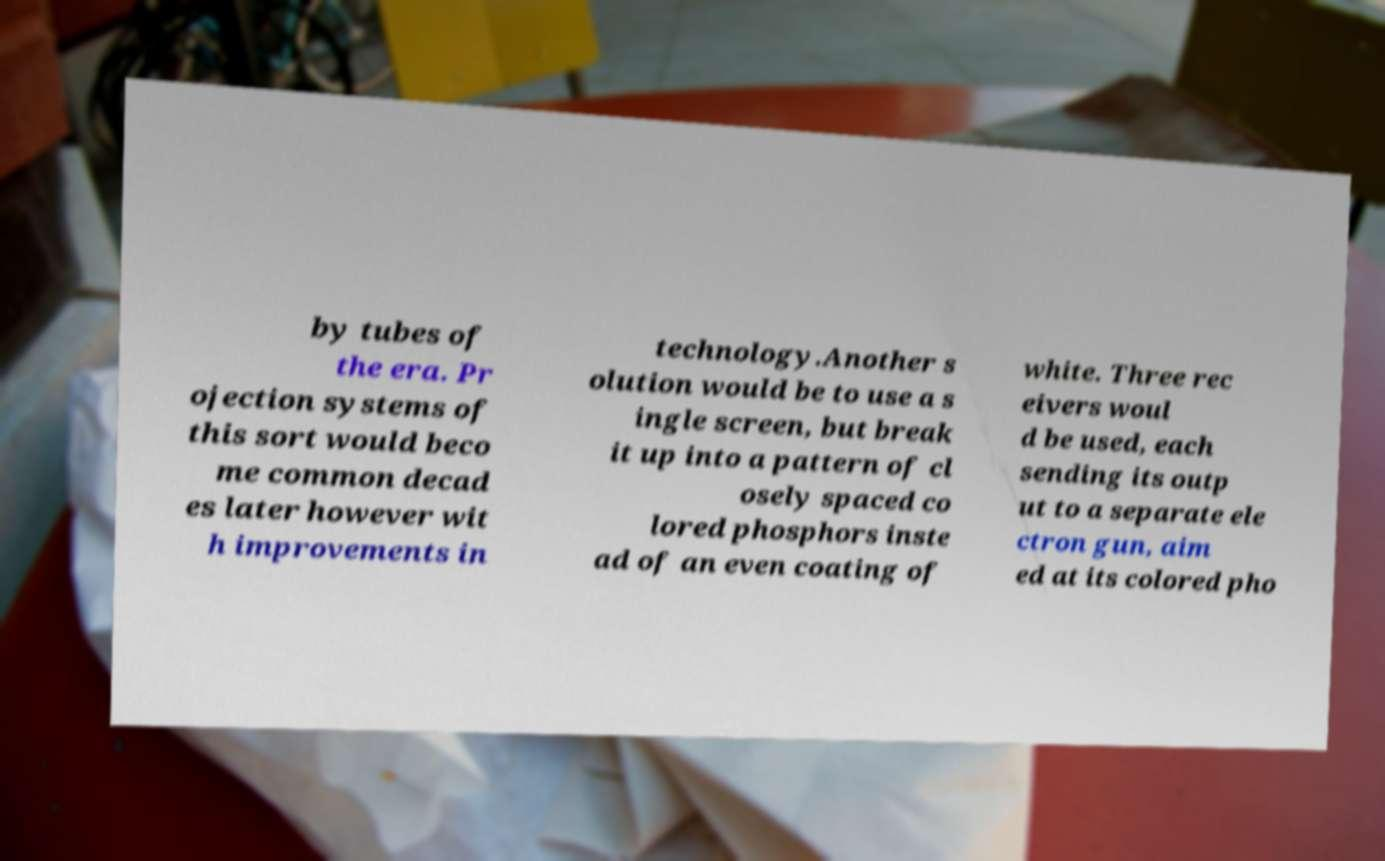Could you extract and type out the text from this image? by tubes of the era. Pr ojection systems of this sort would beco me common decad es later however wit h improvements in technology.Another s olution would be to use a s ingle screen, but break it up into a pattern of cl osely spaced co lored phosphors inste ad of an even coating of white. Three rec eivers woul d be used, each sending its outp ut to a separate ele ctron gun, aim ed at its colored pho 